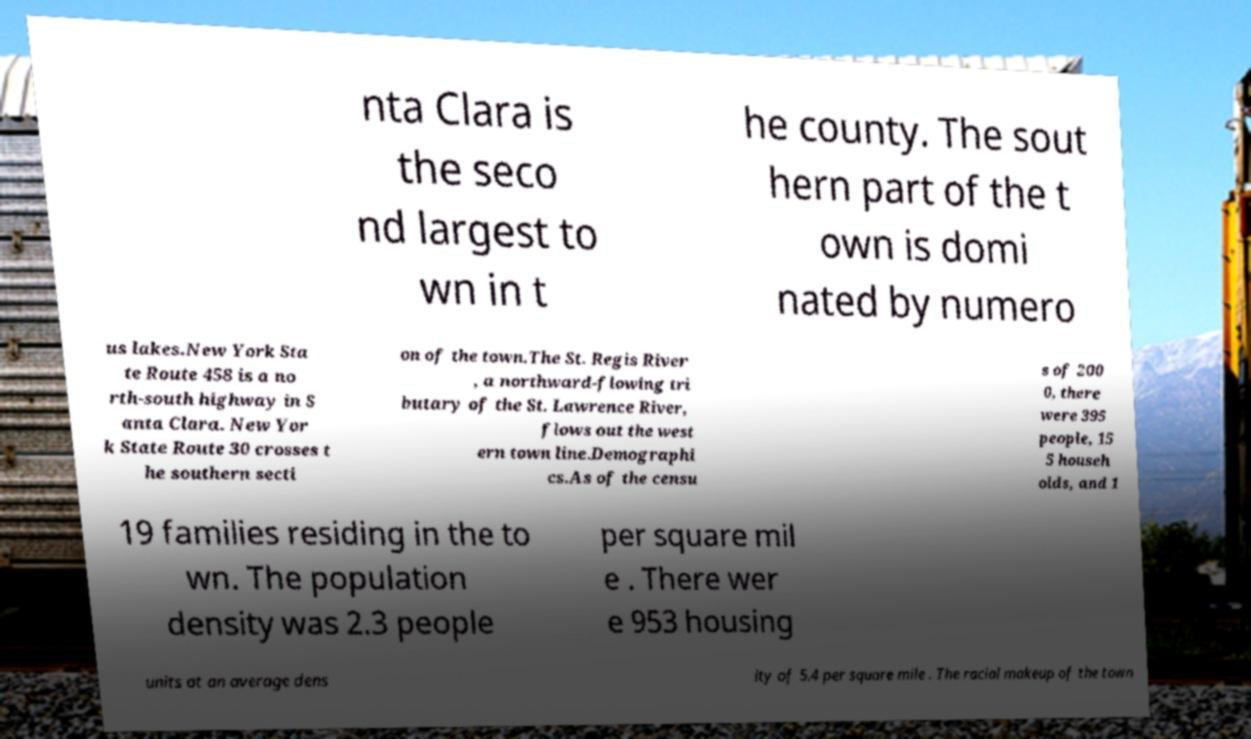Can you read and provide the text displayed in the image?This photo seems to have some interesting text. Can you extract and type it out for me? nta Clara is the seco nd largest to wn in t he county. The sout hern part of the t own is domi nated by numero us lakes.New York Sta te Route 458 is a no rth-south highway in S anta Clara. New Yor k State Route 30 crosses t he southern secti on of the town.The St. Regis River , a northward-flowing tri butary of the St. Lawrence River, flows out the west ern town line.Demographi cs.As of the censu s of 200 0, there were 395 people, 15 5 househ olds, and 1 19 families residing in the to wn. The population density was 2.3 people per square mil e . There wer e 953 housing units at an average dens ity of 5.4 per square mile . The racial makeup of the town 